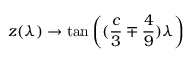Convert formula to latex. <formula><loc_0><loc_0><loc_500><loc_500>z ( \lambda ) \rightarrow \tan \left ( ( \frac { c } { 3 } \mp \frac { 4 } { 9 } ) \lambda \right )</formula> 